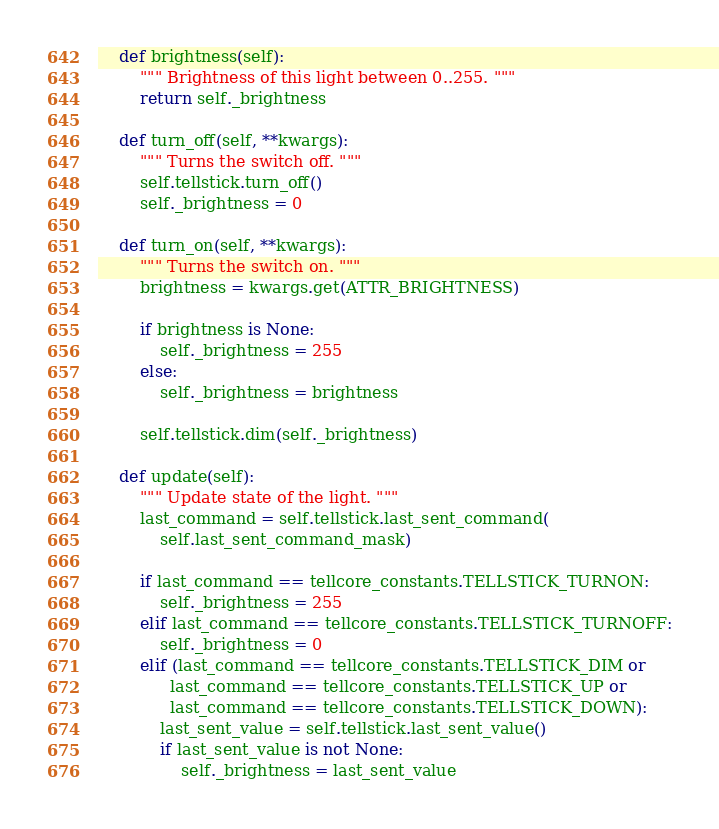Convert code to text. <code><loc_0><loc_0><loc_500><loc_500><_Python_>    def brightness(self):
        """ Brightness of this light between 0..255. """
        return self._brightness

    def turn_off(self, **kwargs):
        """ Turns the switch off. """
        self.tellstick.turn_off()
        self._brightness = 0

    def turn_on(self, **kwargs):
        """ Turns the switch on. """
        brightness = kwargs.get(ATTR_BRIGHTNESS)

        if brightness is None:
            self._brightness = 255
        else:
            self._brightness = brightness

        self.tellstick.dim(self._brightness)

    def update(self):
        """ Update state of the light. """
        last_command = self.tellstick.last_sent_command(
            self.last_sent_command_mask)

        if last_command == tellcore_constants.TELLSTICK_TURNON:
            self._brightness = 255
        elif last_command == tellcore_constants.TELLSTICK_TURNOFF:
            self._brightness = 0
        elif (last_command == tellcore_constants.TELLSTICK_DIM or
              last_command == tellcore_constants.TELLSTICK_UP or
              last_command == tellcore_constants.TELLSTICK_DOWN):
            last_sent_value = self.tellstick.last_sent_value()
            if last_sent_value is not None:
                self._brightness = last_sent_value
</code> 